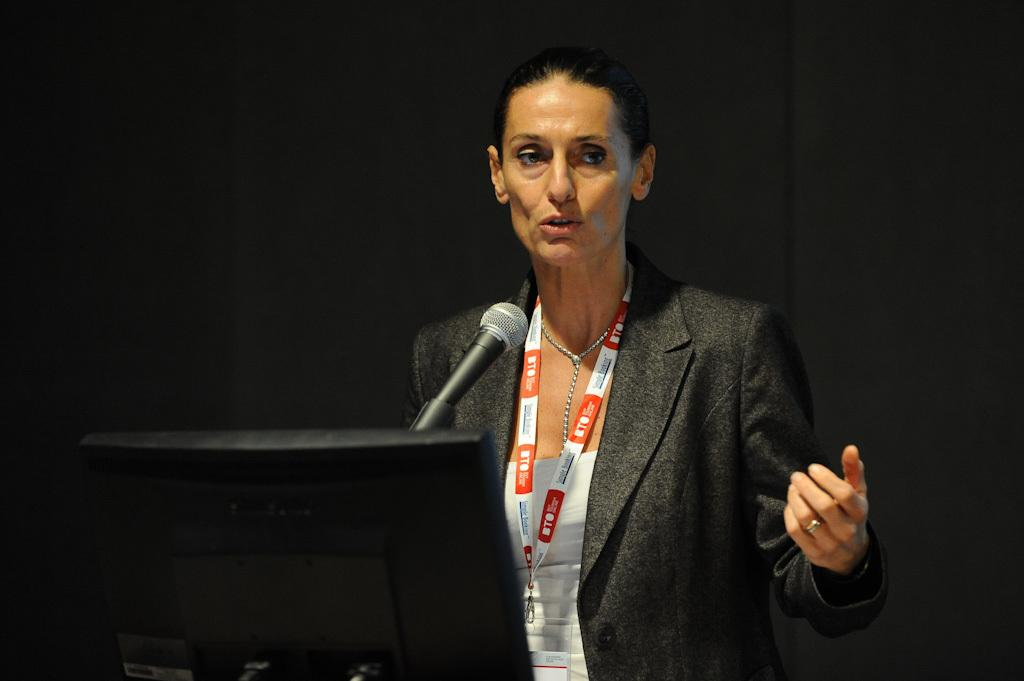What is the main subject of the image? There is a woman standing in the image. What objects are in front of the woman? There is a monitor and a microphone (mike) in front of the woman. How would you describe the lighting in the image? The background of the image appears dark. What type of punishment is being administered in the image? There is no indication of punishment in the image; it features a woman standing with a monitor and a microphone in front of her. What flavor of ice cream is being served at the cemetery in the image? There is no ice cream or cemetery present in the image. 